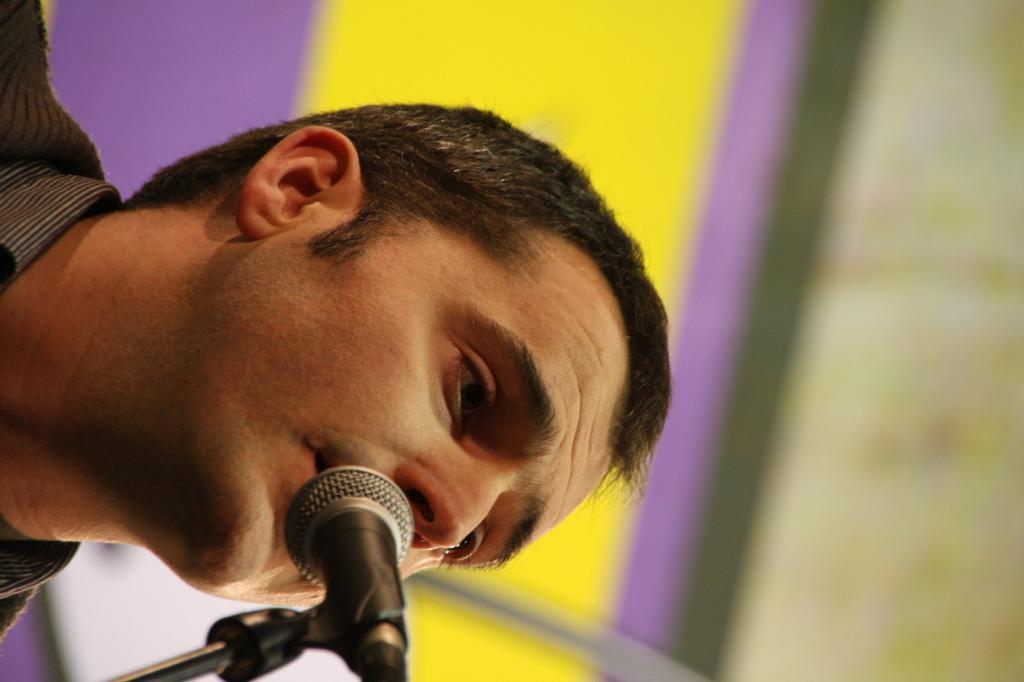In one or two sentences, can you explain what this image depicts? In this picture there is a person and in the foreground there is a microphone. At the back there is a board and the image is blurry. 